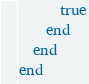Convert code to text. <code><loc_0><loc_0><loc_500><loc_500><_Ruby_>      true
    end
  end
end
</code> 